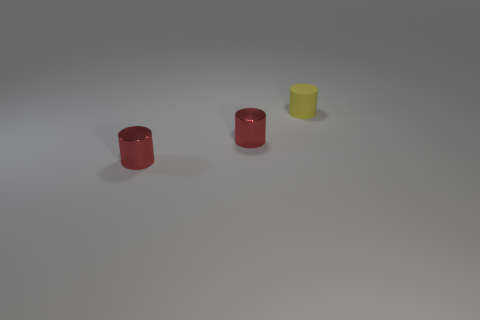How many objects are big metallic spheres or yellow rubber things?
Give a very brief answer. 1. What number of balls are either small matte objects or red shiny objects?
Make the answer very short. 0. Are there any tiny cylinders on the left side of the matte object?
Give a very brief answer. Yes. How many things are either tiny cylinders that are on the left side of the small rubber cylinder or small yellow cylinders?
Your response must be concise. 3. What number of other objects are there of the same material as the small yellow cylinder?
Make the answer very short. 0. Is the number of metallic cylinders greater than the number of tiny rubber cylinders?
Offer a very short reply. Yes. Are there fewer yellow things that are in front of the yellow matte thing than large brown cylinders?
Provide a short and direct response. No. What number of tiny matte objects are the same color as the small rubber cylinder?
Give a very brief answer. 0. Is the number of small gray metal things less than the number of tiny red cylinders?
Give a very brief answer. Yes. What number of other things are there of the same size as the rubber cylinder?
Provide a short and direct response. 2. 